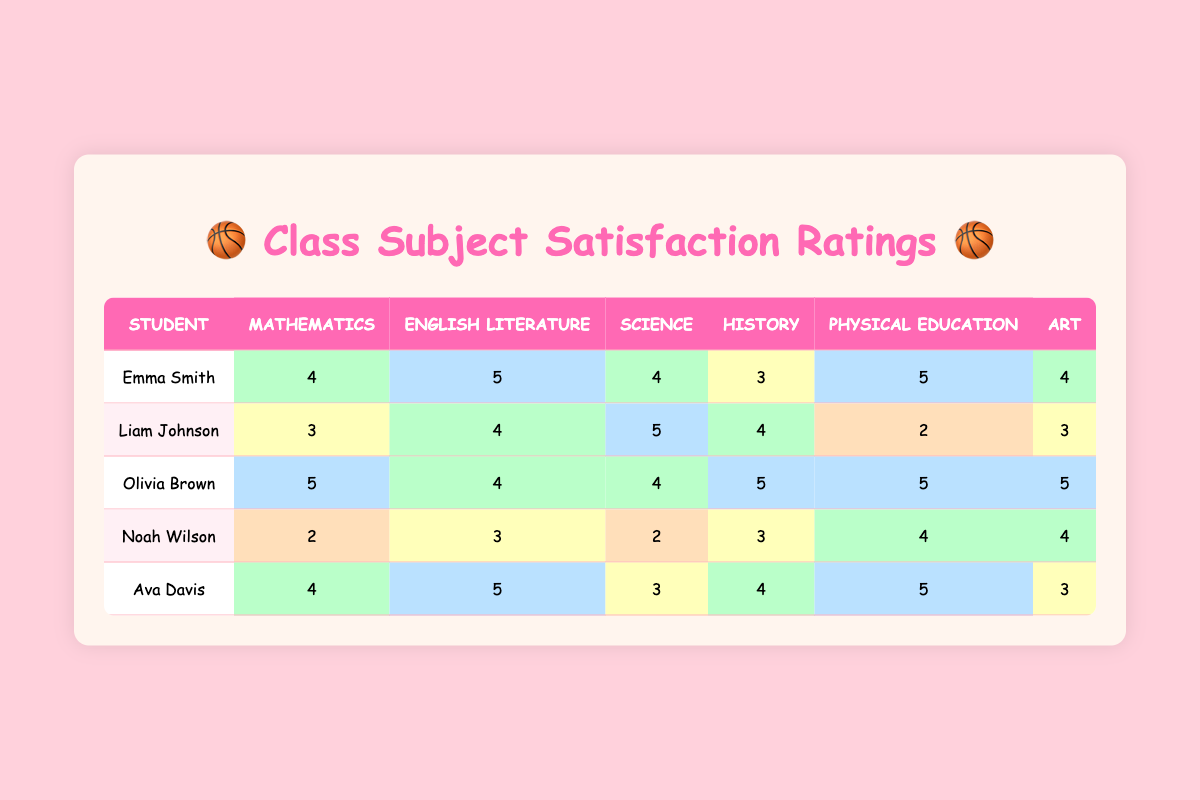What is Emma Smith's rating for English Literature? According to the table, Emma Smith's rating for English Literature is found in the corresponding row under the English Literature column, which shows a score of 5.
Answer: 5 Which student rated Physical Education the lowest? By looking down the Physical Education column, Liam Johnson shows the lowest score of 2 for Physical Education.
Answer: Liam Johnson What is the average rating for Science among all students? To calculate the average, first add all the scores for Science: (4 + 5 + 4 + 2 + 3) = 18. There are 5 students, so average = 18 / 5 = 3.6.
Answer: 3.6 Did any student rate Art a 5? Checking the Art column, Olivia Brown rated Art a 5, confirming that at least one student did give a perfect score for this subject.
Answer: Yes Which subject received the highest average rating? First, sum the ratings for each subject and then divide by the number of students: 
- Mathematics: (4 + 3 + 5 + 2 + 4) = 18, average = 18 / 5 = 3.6,
- English Literature: (5 + 4 + 4 + 3 + 5) = 21, average = 21 / 5 = 4.2,
- Science: (4 + 5 + 4 + 2 + 3) = 18, average = 18 / 5 = 3.6,
- History: (3 + 4 + 5 + 3 + 4) = 19, average = 19 / 5 = 3.8,
- Physical Education: (5 + 2 + 5 + 4 + 5) = 21, average = 21 / 5 = 4.2,
- Art: (4 + 3 + 5 + 4 + 3) = 19, average = 19 / 5 = 3.8. The highest average is 4.2 for both English Literature and Physical Education.
Answer: English Literature and Physical Education What is the rating difference for Mathematics between Olivia Brown and Noah Wilson? Olivia Brown rated Mathematics 5, while Noah Wilson rated it 2. The difference is calculated as 5 - 2 = 3.
Answer: 3 Which student rated Science the highest? Observing the Science column, Liam Johnson rated Science a 5, which is the highest score in that subject.
Answer: Liam Johnson Was the overall rating for History above 3? Adding the ratings for History gives us (3 + 4 + 5 + 3 + 4) = 19. Dividing by the number of students (5) gives average = 19 / 5 = 3.8, which is above 3.
Answer: Yes 